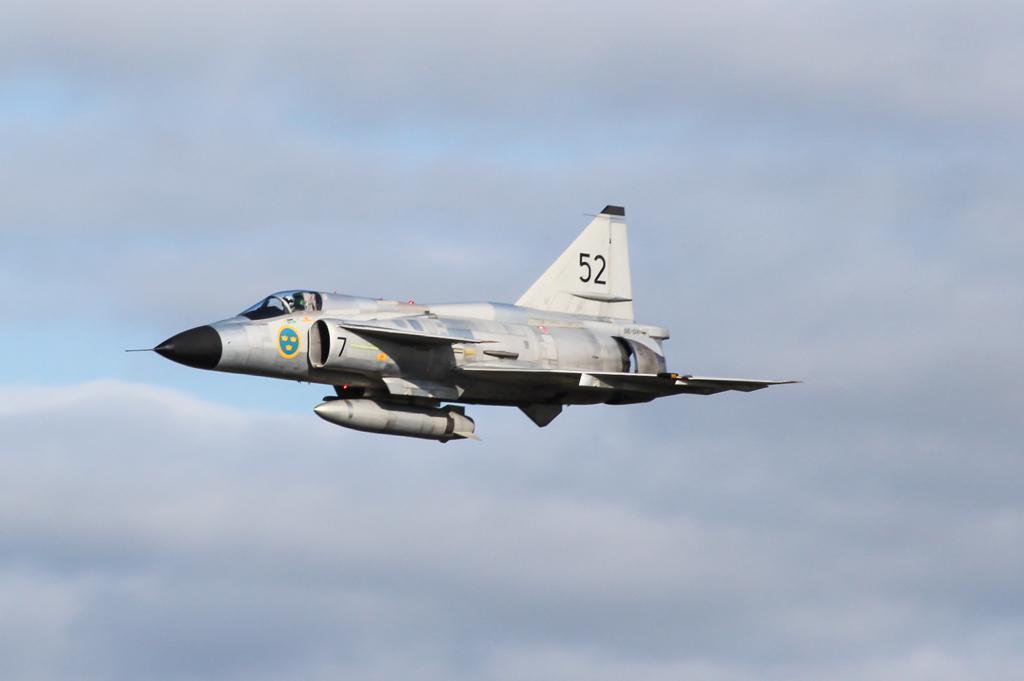What number does it say on the plane?
Offer a very short reply. 52. 